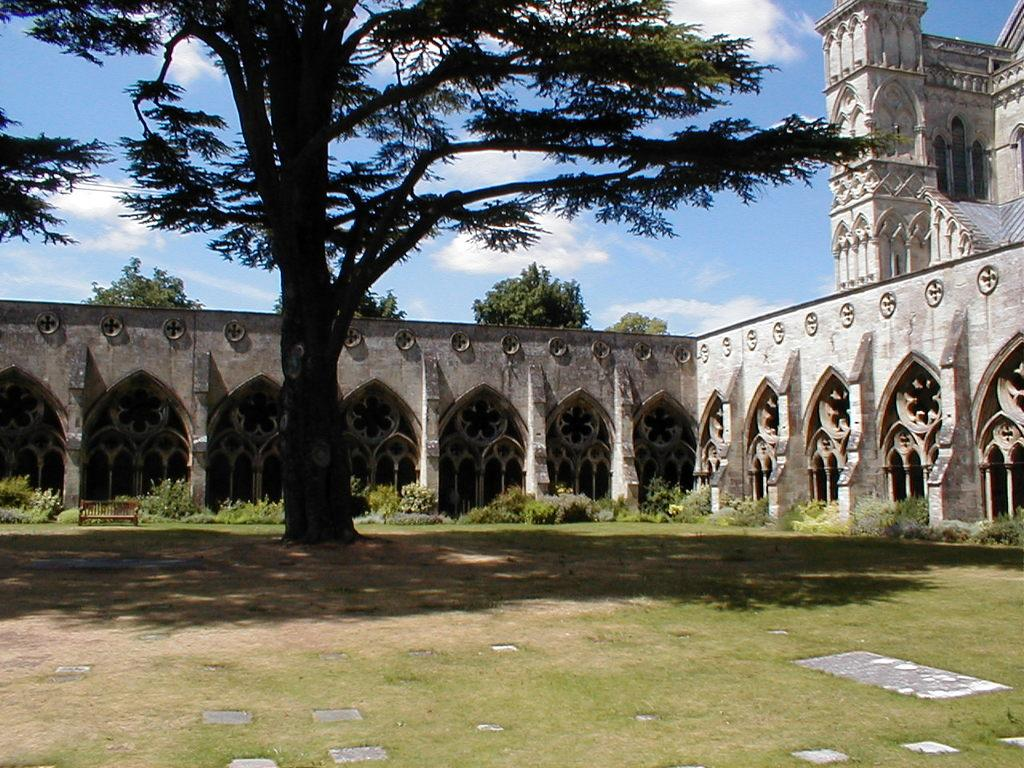What type of vegetation can be seen in the image? There is grass and a tree in the image. What is the ground like in the image? The ground is visible in the image. What architectural features are present in the image? There are pillars and a building in the image. What can be seen in the background of the image? There are trees and the sky in the background of the image. What is the condition of the sky in the image? Clouds are present in the sky. What type of window can be seen in the image? There is no window present in the image. What color is the mark on the tree in the image? There is no mark on the tree in the image. 